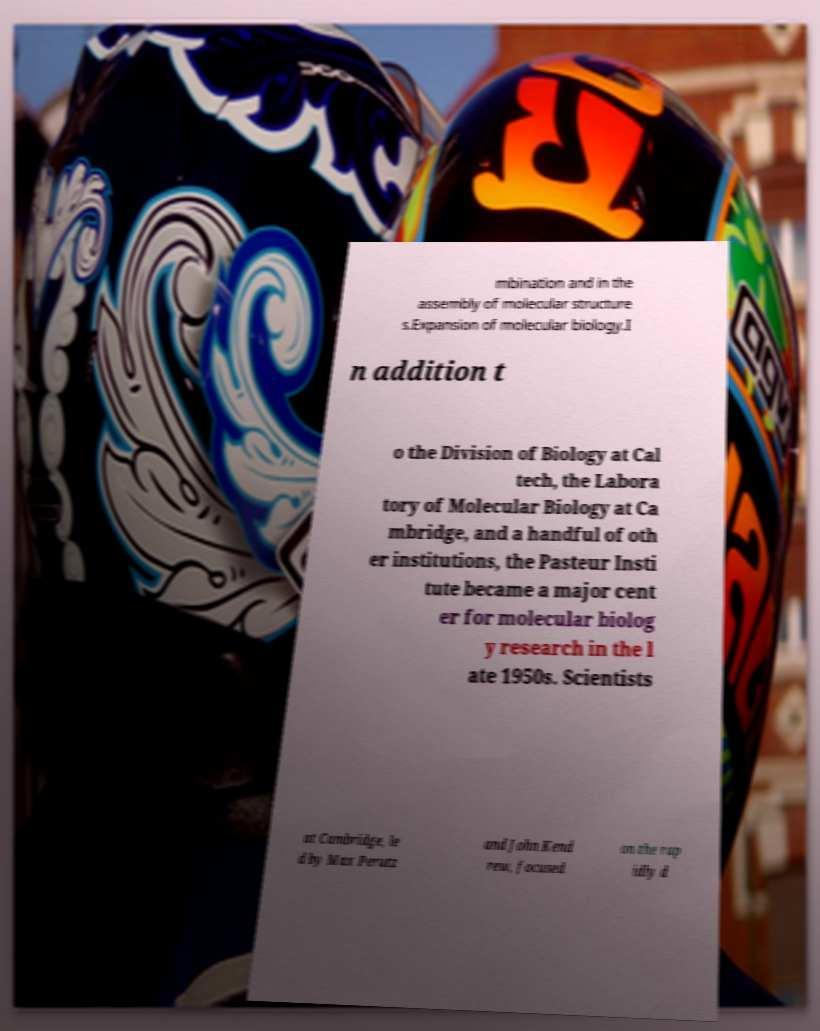Please read and relay the text visible in this image. What does it say? mbination and in the assembly of molecular structure s.Expansion of molecular biology.I n addition t o the Division of Biology at Cal tech, the Labora tory of Molecular Biology at Ca mbridge, and a handful of oth er institutions, the Pasteur Insti tute became a major cent er for molecular biolog y research in the l ate 1950s. Scientists at Cambridge, le d by Max Perutz and John Kend rew, focused on the rap idly d 